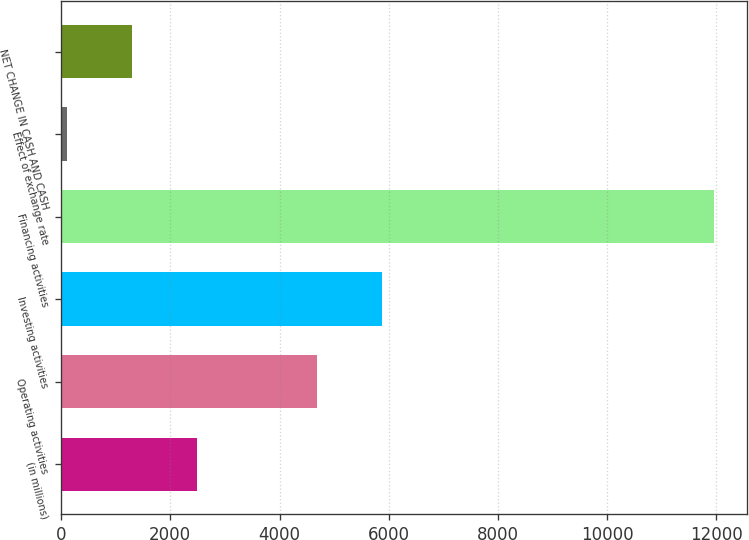Convert chart to OTSL. <chart><loc_0><loc_0><loc_500><loc_500><bar_chart><fcel>(in millions)<fcel>Operating activities<fcel>Investing activities<fcel>Financing activities<fcel>Effect of exchange rate<fcel>NET CHANGE IN CASH AND CASH<nl><fcel>2482<fcel>4684<fcel>5868<fcel>11954<fcel>114<fcel>1298<nl></chart> 